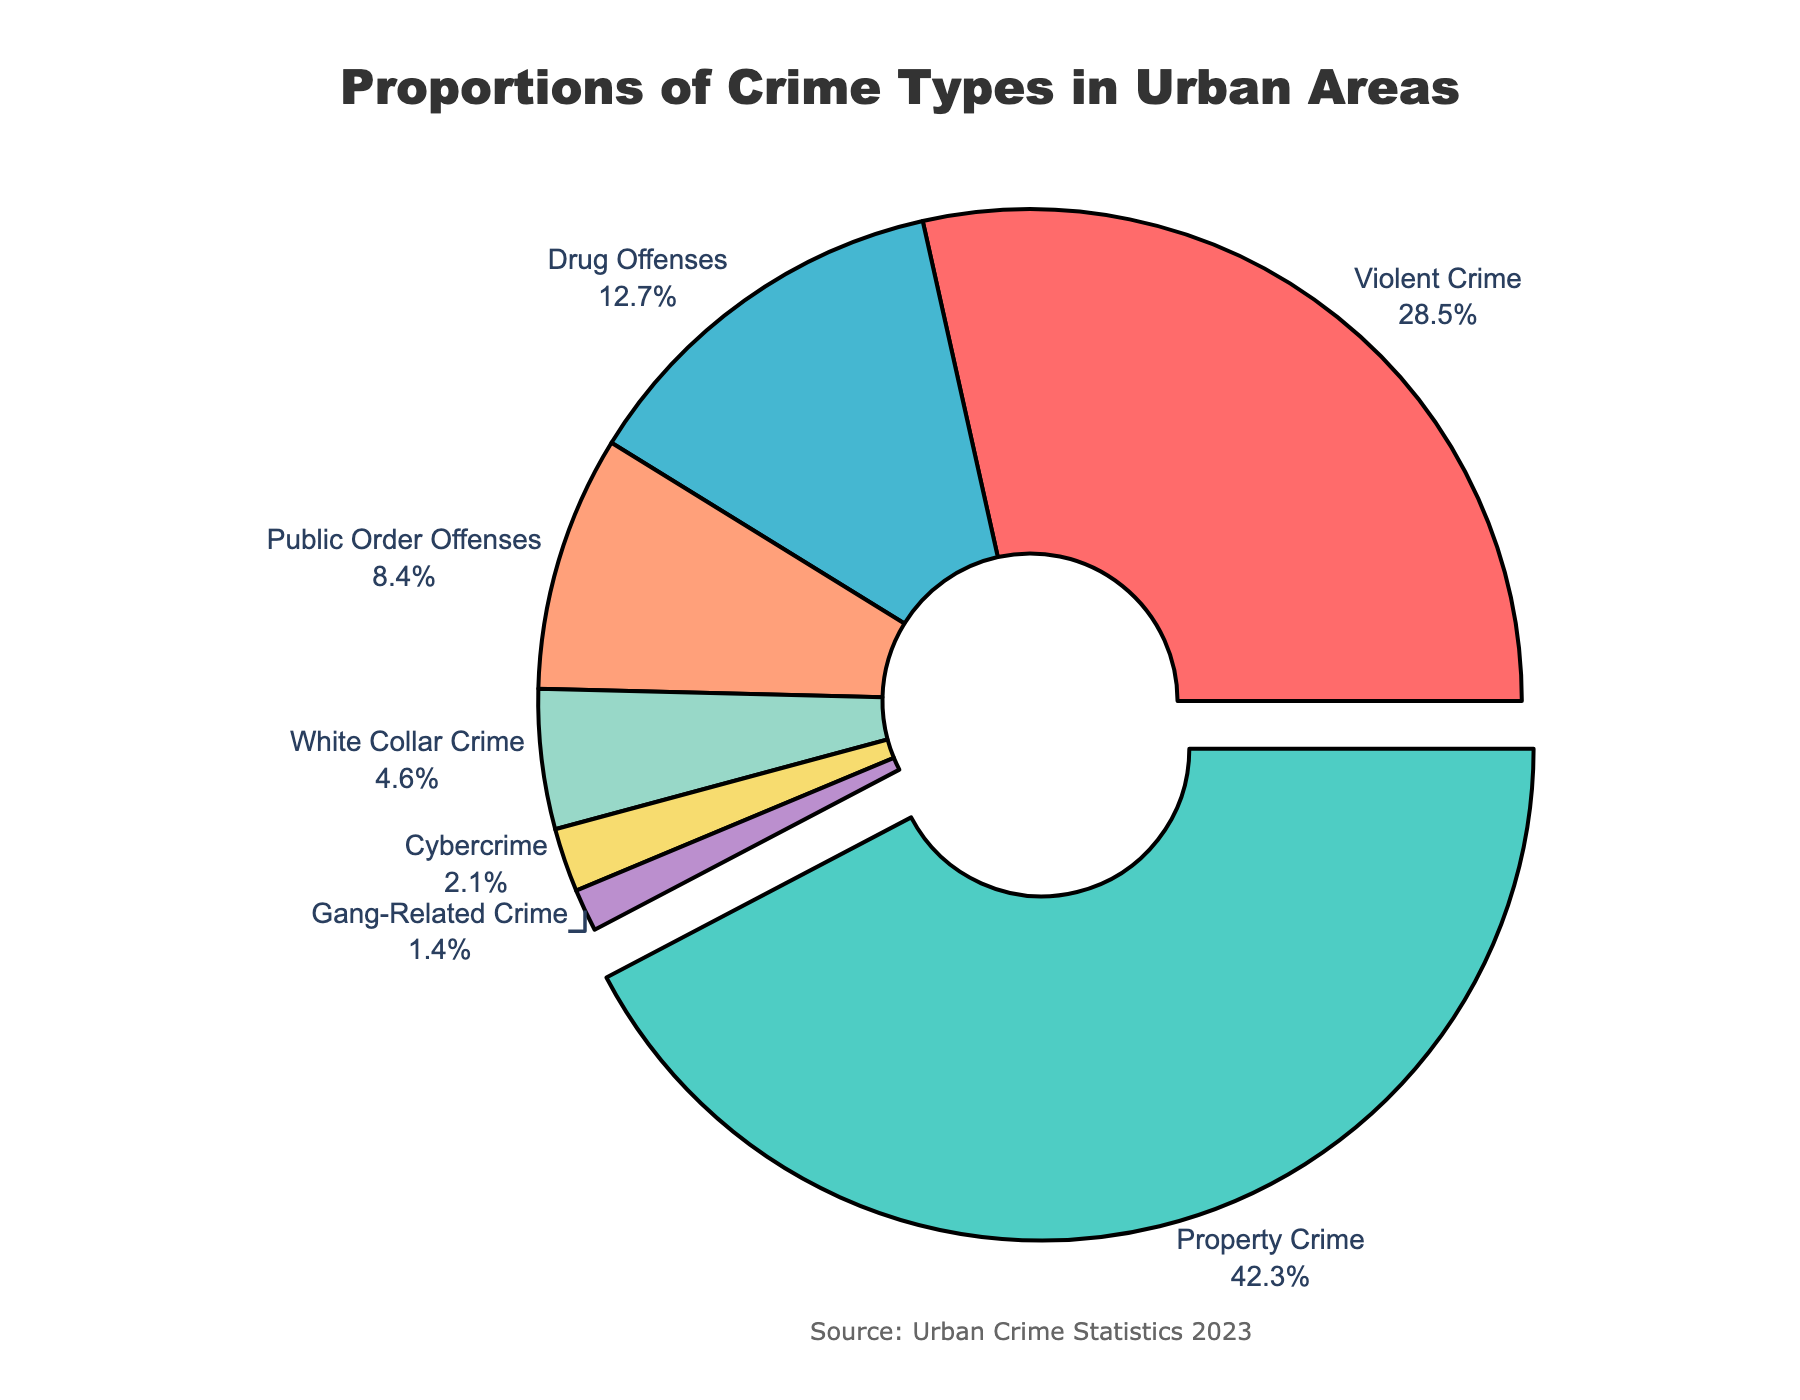What proportion of crime types is consisted of Property Crime and Violent Crime combined? Add the percentages of Property Crime and Violent Crime from the figure: 42.3% + 28.5% = 70.8%
Answer: 70.8% Which crime type has the highest proportion? Identify the crime type with the largest percentage in the pie chart, which is 42.3%. This corresponds to Property Crime.
Answer: Property Crime How much larger is the proportion of Public Order Offenses compared to Cybercrime? Subtract the percentage of Cybercrime from the percentage of Public Order Offenses: 8.4% - 2.1% = 6.3%
Answer: 6.3% What is the proportion difference between Drug Offenses and White Collar Crime? Subtract the percentage of White Collar Crime from the percentage of Drug Offenses: 12.7% - 4.6% = 8.1%
Answer: 8.1% Which crime type is represented by the red portion of the pie chart? From the given information about the colors, the red portion is used for Violent Crime.
Answer: Violent Crime Ratio of the proportion of Drug Offenses to Gang-Related Crime? Divide the percentage of Drug Offenses by the percentage of Gang-Related Crime: 12.7% / 1.4% ≈ 9.07
Answer: 9.07 What color represents Property Crime? From the given information about the colors, Property Crime is represented by the green portion of the pie chart.
Answer: Green What is the combined proportion of Drug Offenses, Public Order Offenses, and White Collar Crime? Add the percentages of Drug Offenses, Public Order Offenses, and White Collar Crime from the figure: 12.7% + 8.4% + 4.6% = 25.7%
Answer: 25.7% Is the proportion of Property Crime greater than twice the proportion of Violent Crime? Calculate twice the proportion of Violent Crime and compare it to Property Crime, 2 * 28.5% = 57.0%. Since 42.3% < 57.0%, the proportion of Property Crime is not greater.
Answer: No 